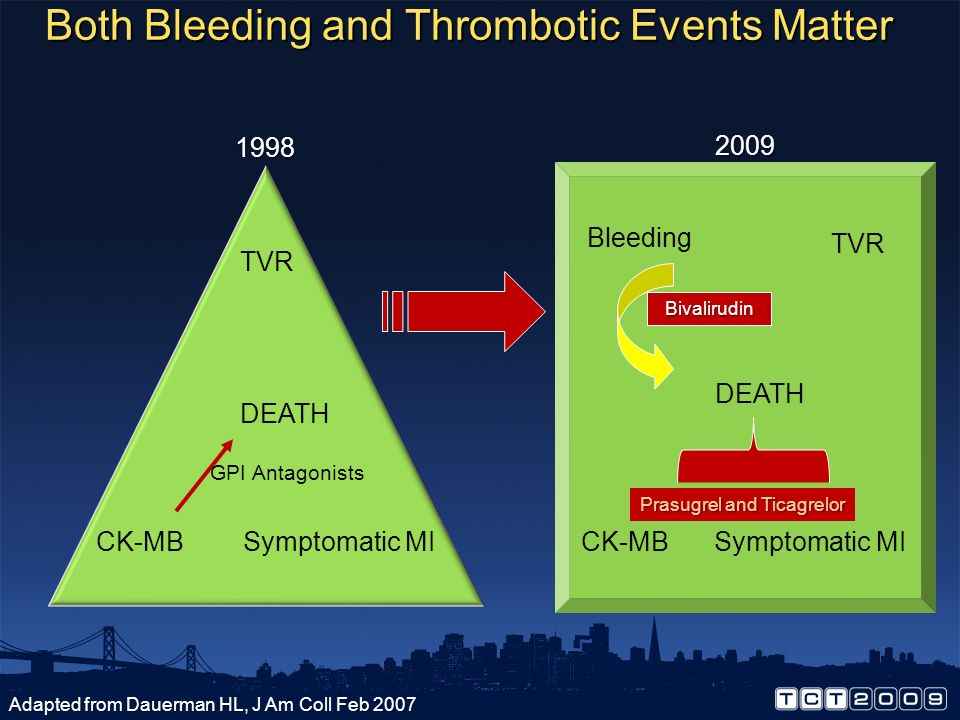What other changes can you infer from the comparison between 1998 and 2009 in terms of medical treatment development? From the comparison between 1998 and 2009, we can infer several important changes in medical treatment development. Firstly, the focus in 1998 was primarily on reducing major events like thrombosis and myocardial infarction (MI), indicated by terms such as CK-MB and symptomatic MI. By 2009, the inclusion of more comprehensive terms like 'Bleeding' and 'Bivalirudin' reflects a nuanced approach to treatment, demonstrating a shift towards balancing and managing both the risks of thrombosis and bleeding. Additionally, the mention of specific medications like Prasugrel and Ticagrelor suggests advancements in pharmacological treatments, highlighting improvements in both efficacy and safety measures over the decade. How do the terms 'TVR' and 'DEATH' in both years contribute to understanding changes in medical priorities? The terms 'TVR' (Target Vessel Revascularization) and 'DEATH' present in both years indicate that these outcomes have remained consistent priorities in medical treatments. However, the evolution in the surrounding context—additional considerations like 'Bleeding' and the introduction of new drugs—implies that while reducing mortality and the need for repeat revascularization remains critical, there is an enhanced effort in addressing the safety and side effects of treatments. The continuity of these terms highlights that foundational objectives have persisted, with a growing complexity in treatment considerations reflecting advancements in medical understanding and patient care priorities. 